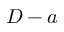Convert formula to latex. <formula><loc_0><loc_0><loc_500><loc_500>D - a</formula> 